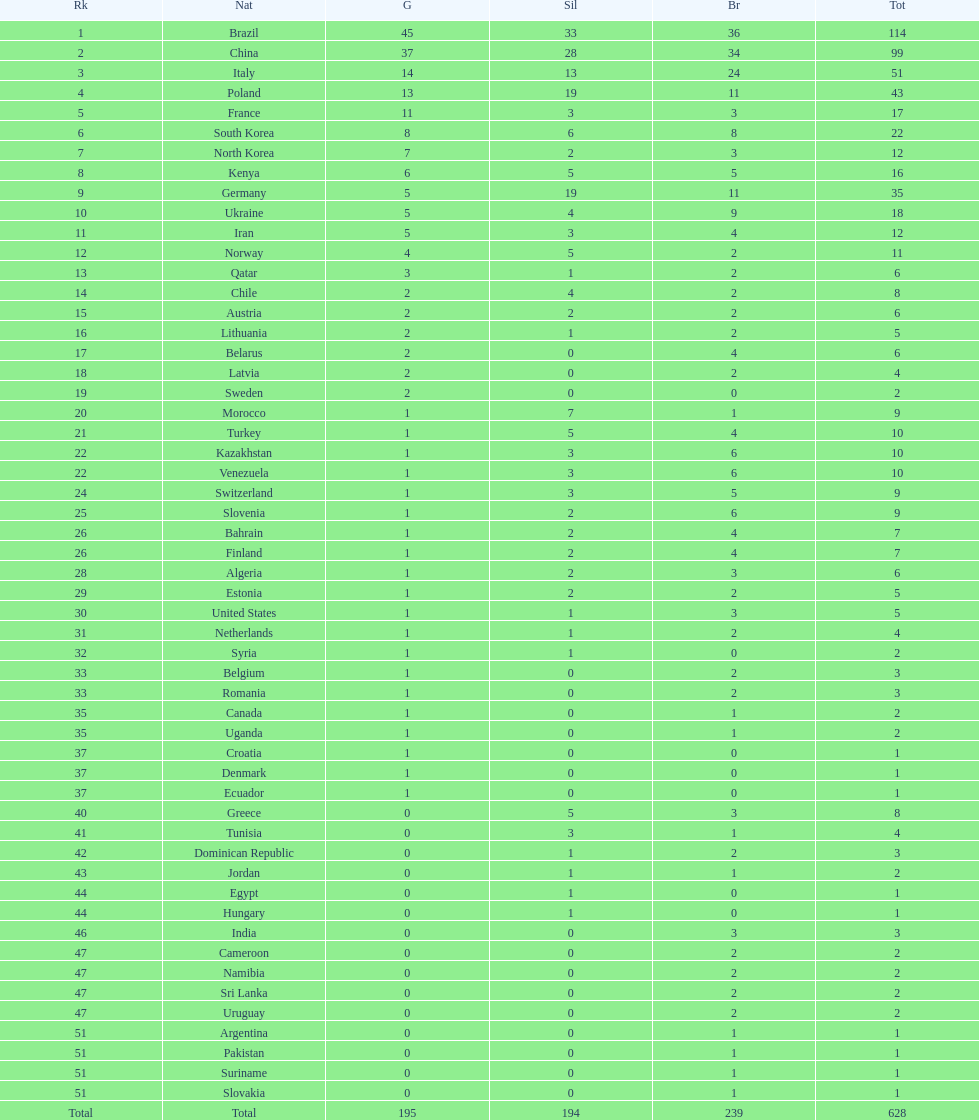South korea has how many more medals that north korea? 10. 